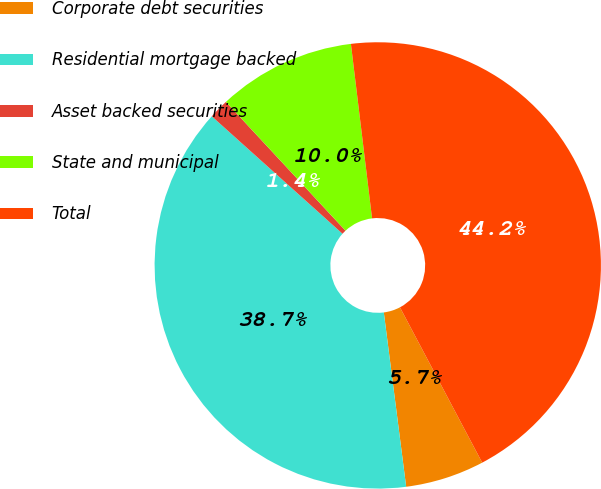Convert chart to OTSL. <chart><loc_0><loc_0><loc_500><loc_500><pie_chart><fcel>Corporate debt securities<fcel>Residential mortgage backed<fcel>Asset backed securities<fcel>State and municipal<fcel>Total<nl><fcel>5.72%<fcel>38.68%<fcel>1.44%<fcel>9.99%<fcel>44.17%<nl></chart> 